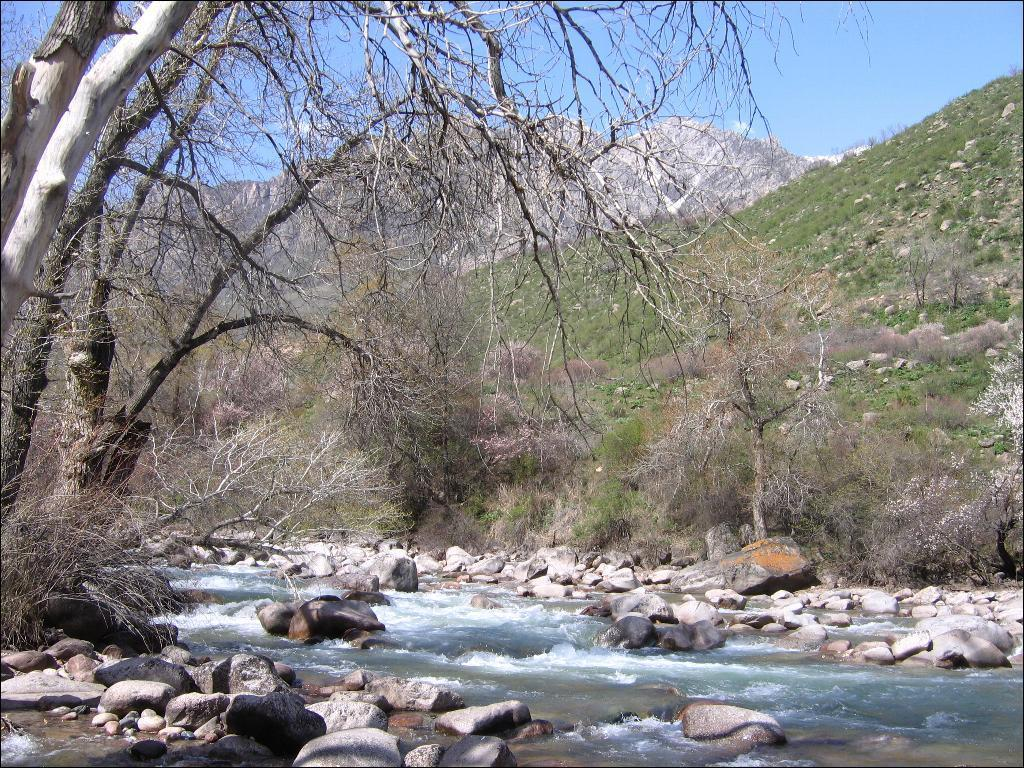What is the primary element in the image? There is water in the image. What can be found within the water? There are stones in the water. What type of natural environment is visible in the background? There are trees and a mountain in the background of the image. What part of the sky is visible in the image? The sky is visible in the background of the image. What type of lettuce is being used as a veil in the image? There is no lettuce or veil present in the image. 